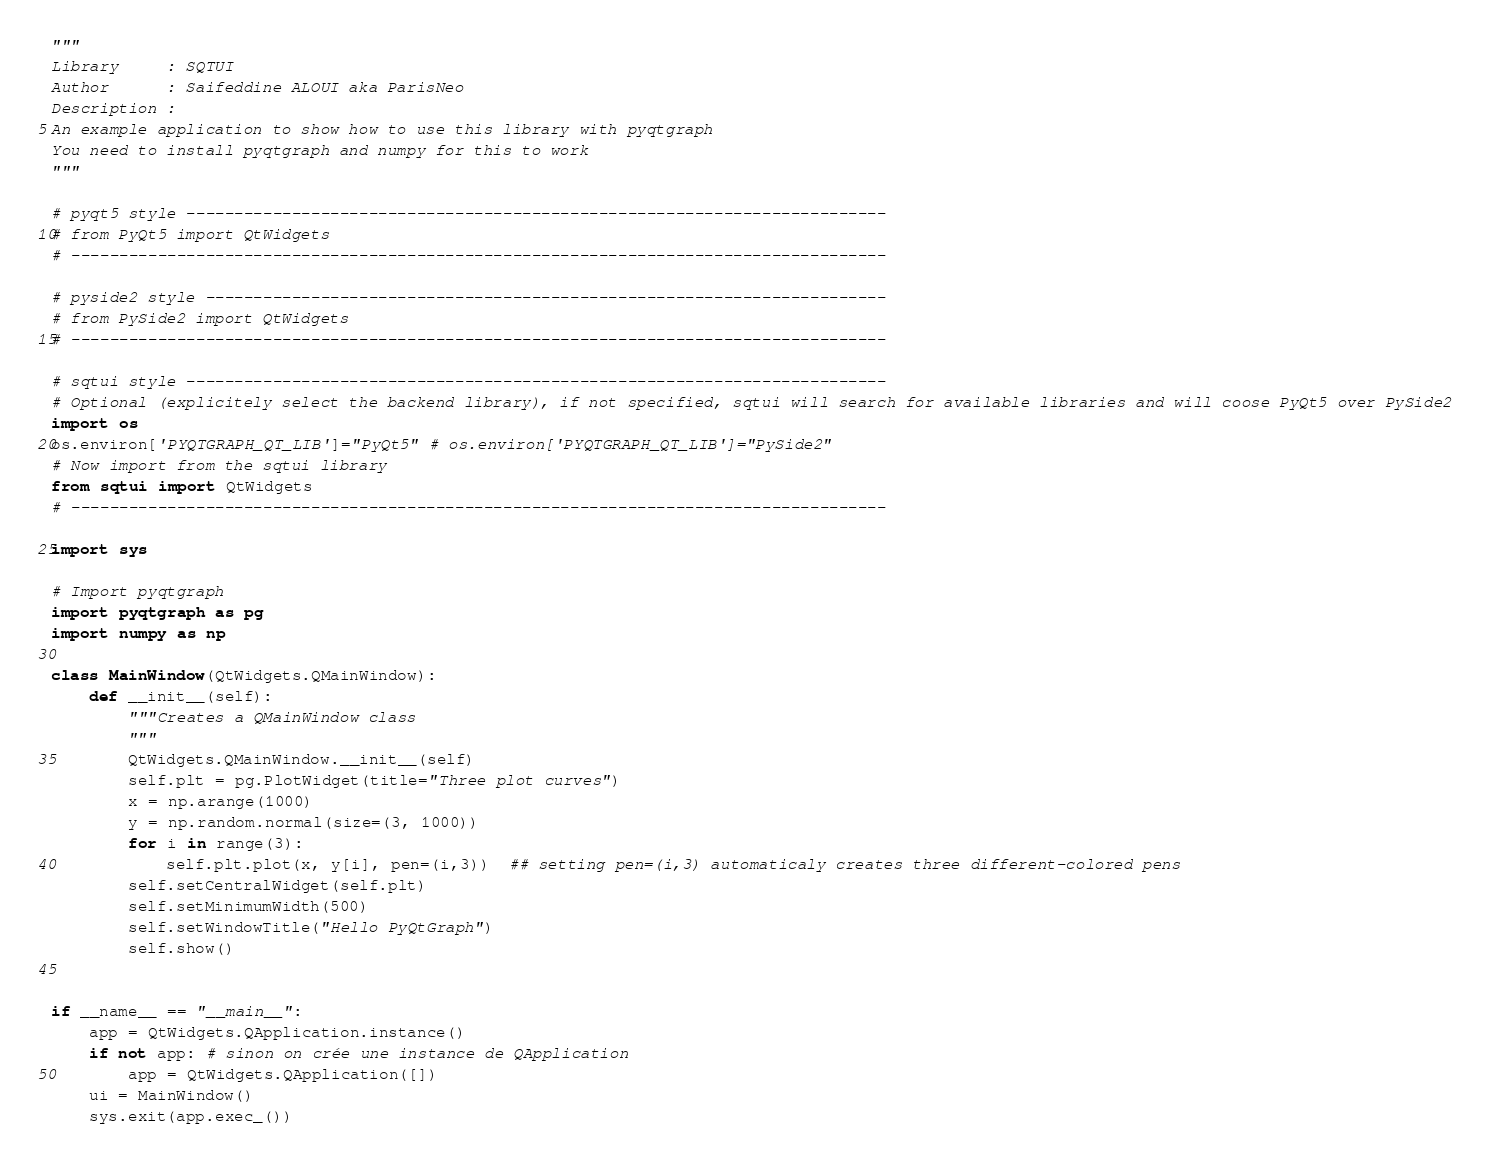<code> <loc_0><loc_0><loc_500><loc_500><_Python_>"""
Library     : SQTUI
Author      : Saifeddine ALOUI aka ParisNeo
Description :
An example application to show how to use this library with pyqtgraph
You need to install pyqtgraph and numpy for this to work
"""

# pyqt5 style -------------------------------------------------------------------------
# from PyQt5 import QtWidgets
# -------------------------------------------------------------------------------------

# pyside2 style -----------------------------------------------------------------------
# from PySide2 import QtWidgets
# -------------------------------------------------------------------------------------

# sqtui style -------------------------------------------------------------------------
# Optional (explicitely select the backend library), if not specified, sqtui will search for available libraries and will coose PyQt5 over PySide2
import os
os.environ['PYQTGRAPH_QT_LIB']="PyQt5" # os.environ['PYQTGRAPH_QT_LIB']="PySide2"
# Now import from the sqtui library
from sqtui import QtWidgets
# -------------------------------------------------------------------------------------

import sys

# Import pyqtgraph
import pyqtgraph as pg
import numpy as np

class MainWindow(QtWidgets.QMainWindow):
    def __init__(self):
        """Creates a QMainWindow class
        """
        QtWidgets.QMainWindow.__init__(self)
        self.plt = pg.PlotWidget(title="Three plot curves")
        x = np.arange(1000)
        y = np.random.normal(size=(3, 1000))
        for i in range(3):
            self.plt.plot(x, y[i], pen=(i,3))  ## setting pen=(i,3) automaticaly creates three different-colored pens
        self.setCentralWidget(self.plt)
        self.setMinimumWidth(500)
        self.setWindowTitle("Hello PyQtGraph")
        self.show()


if __name__ == "__main__":
    app = QtWidgets.QApplication.instance()
    if not app: # sinon on crée une instance de QApplication
        app = QtWidgets.QApplication([])
    ui = MainWindow()
    sys.exit(app.exec_())


</code> 